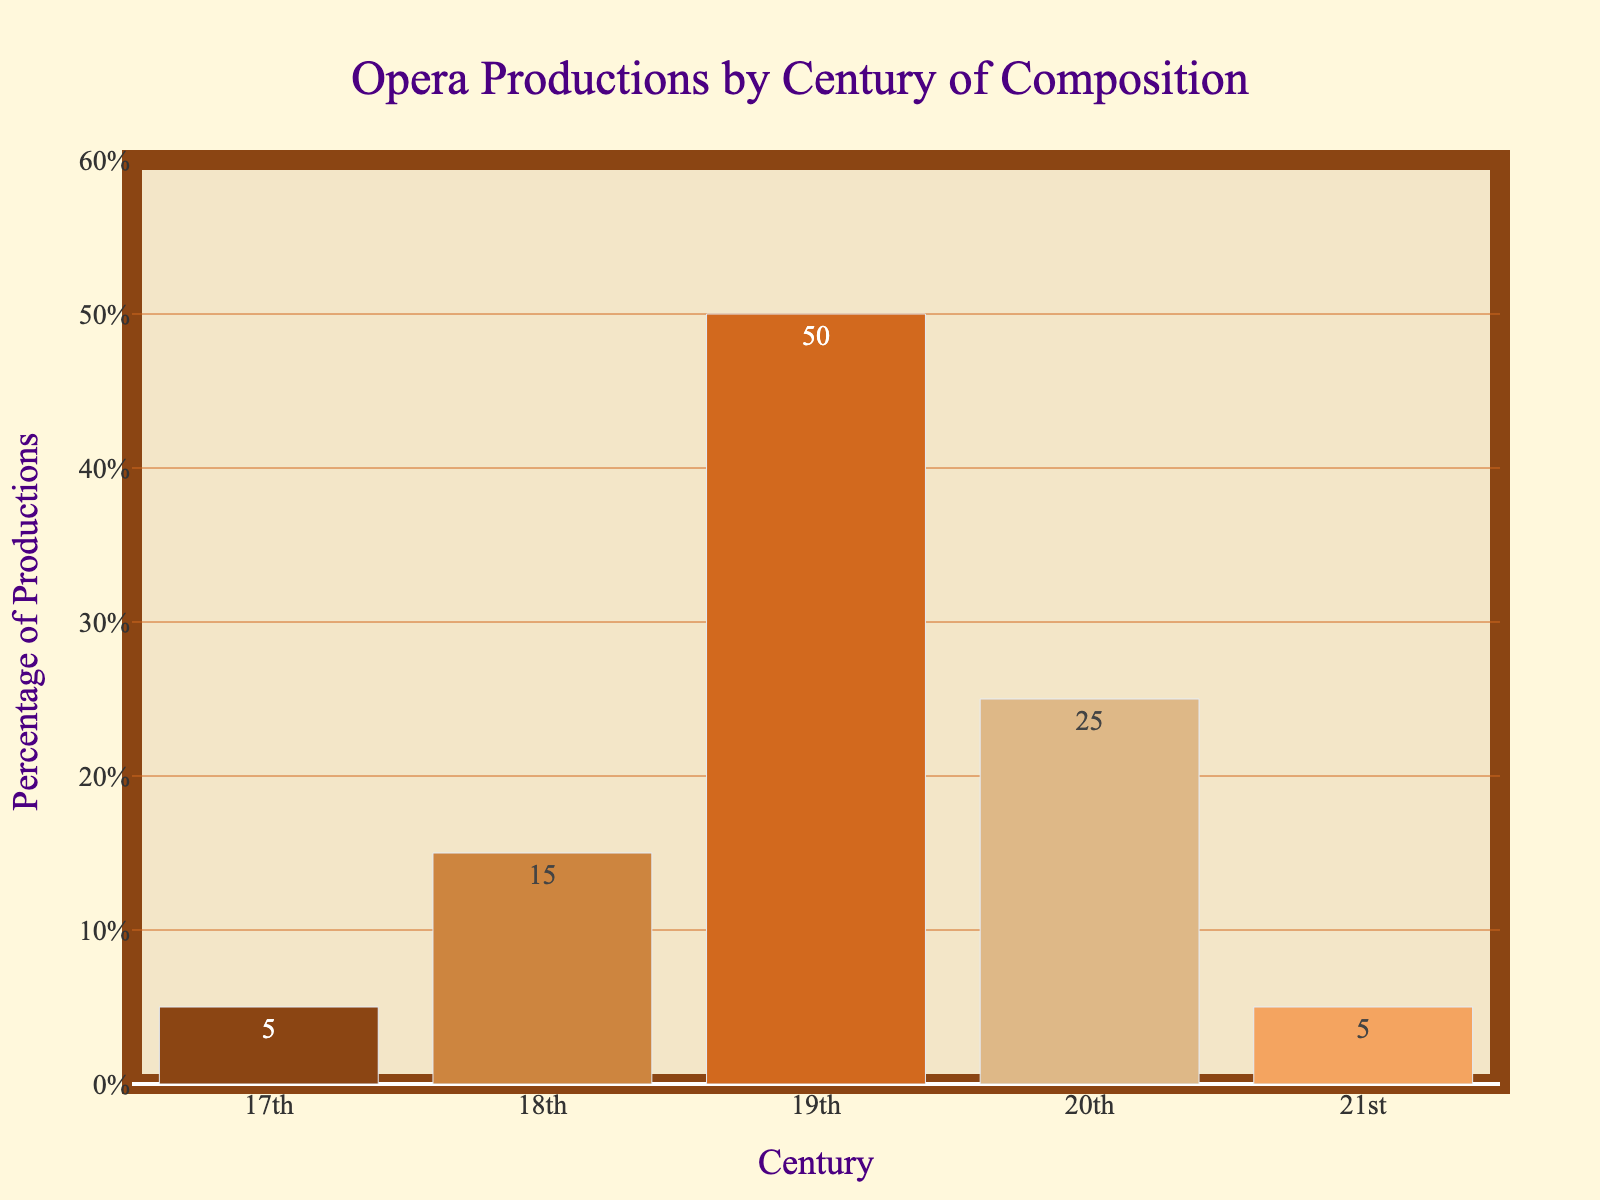What century has the highest percentage of opera productions? The y-axis indicates the percentage of productions, and the highest bar represents the 19th century with 50%.
Answer: 19th century Which two centuries have the same percentage of opera productions? Observing the heights of the bars in the plot, the 17th and 21st centuries each represent 5% of productions.
Answer: 17th and 21st centuries How much greater is the percentage of productions for the 19th century compared to the 20th century? The percentage for the 19th century is 50%, and the percentage for the 20th century is 25%. The difference is 50% - 25% = 25%.
Answer: 25% What is the combined percentage of productions for the 17th, 18th, and 21st centuries? Adding the percentages: 17th (5%) + 18th (15%) + 21st (5%) = 5% + 15% + 5% = 25%.
Answer: 25% Which century has the least percentage of productions and what is the value? The smallest bar represents both the 17th and 21st centuries, each with a 5% share of productions.
Answer: 17th and 21st centuries, 5% What are the colors of the bars representing the 18th and 20th centuries? The bar for the 18th century is light brown (sandy), and the bar for the 20th century is light tan (beige).
Answer: Light brown (18th century) and light tan (20th century) What is the average percentage of productions across all centuries? Summing the percentages: 5% + 15% + 50% + 25% + 5% = 100%. Then, dividing by the number of centuries (5): 100% / 5 = 20%.
Answer: 20% In which century does the percentage of productions fall between 10% and 30%? The y-axis shows that the 18th century falls within this range with 15%.
Answer: 18th century What is the difference in percentage between the century with the highest productions and the next highest? The highest is 19th (50%) and the next is the 20th century (25%), so the difference is 50% - 25% = 25%.
Answer: 25% Which century's bar is visually closest in height to the 17th century's bar? The heights of the bars for the 17th and 21st centuries are the same at 5%.
Answer: 21st century 